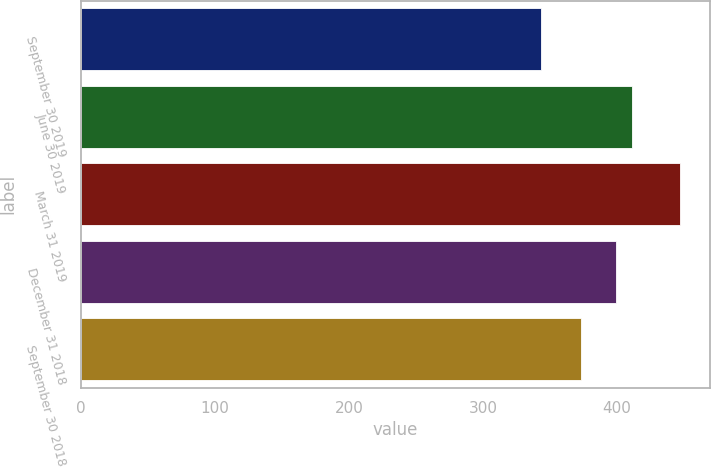<chart> <loc_0><loc_0><loc_500><loc_500><bar_chart><fcel>September 30 2019<fcel>June 30 2019<fcel>March 31 2019<fcel>December 31 2018<fcel>September 30 2018<nl><fcel>343<fcel>411<fcel>447<fcel>399<fcel>373<nl></chart> 